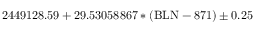<formula> <loc_0><loc_0><loc_500><loc_500>2 4 4 9 1 2 8 . 5 9 + 2 9 . 5 3 0 5 8 8 6 7 * ( B L N - 8 7 1 ) \pm 0 . 2 5</formula> 